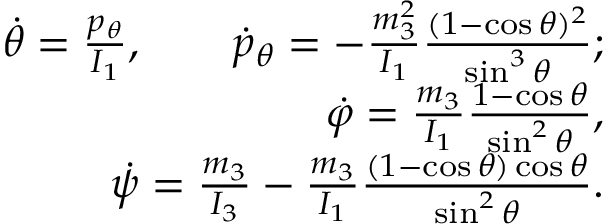<formula> <loc_0><loc_0><loc_500><loc_500>\begin{array} { r } { \dot { \theta } = \frac { p _ { \theta } } { I _ { 1 } } , \quad \dot { p } _ { \theta } = - \frac { m _ { 3 } ^ { 2 } } { I _ { 1 } } \frac { ( 1 - \cos \theta ) ^ { 2 } } { \sin ^ { 3 } \theta } ; } \\ { \dot { \varphi } = \frac { m _ { 3 } } { I _ { 1 } } \frac { 1 - \cos \theta } { \sin ^ { 2 } \theta } , } \\ { \dot { \psi } = \frac { m _ { 3 } } { I _ { 3 } } - \frac { m _ { 3 } } { I _ { 1 } } \frac { ( 1 - \cos \theta ) \cos \theta } { \sin ^ { 2 } \theta } . } \end{array}</formula> 